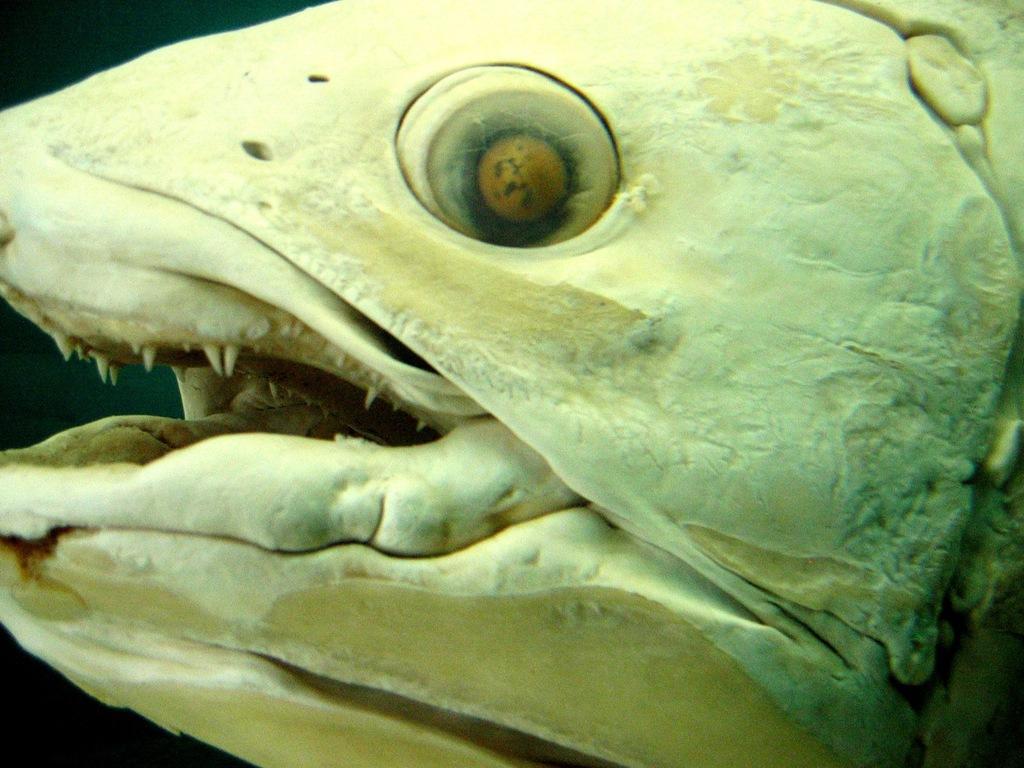Could you give a brief overview of what you see in this image? In this image, I can see the head of a fish. There is a dark background. 